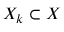Convert formula to latex. <formula><loc_0><loc_0><loc_500><loc_500>X _ { k } \subset X</formula> 